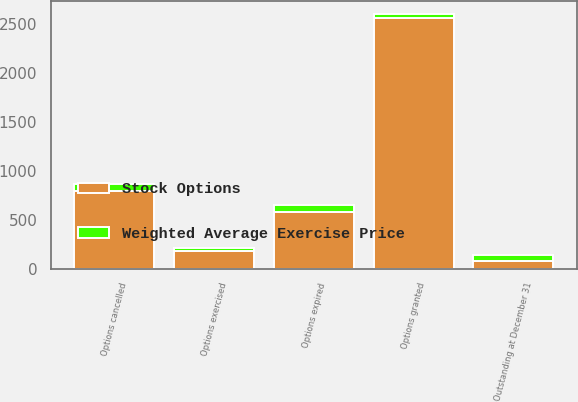Convert chart to OTSL. <chart><loc_0><loc_0><loc_500><loc_500><stacked_bar_chart><ecel><fcel>Outstanding at December 31<fcel>Options granted<fcel>Options exercised<fcel>Options cancelled<fcel>Options expired<nl><fcel>Stock Options<fcel>73.405<fcel>2567<fcel>176<fcel>799<fcel>580<nl><fcel>Weighted Average Exercise Price<fcel>67.17<fcel>40.12<fcel>30.32<fcel>63.61<fcel>75.56<nl></chart> 